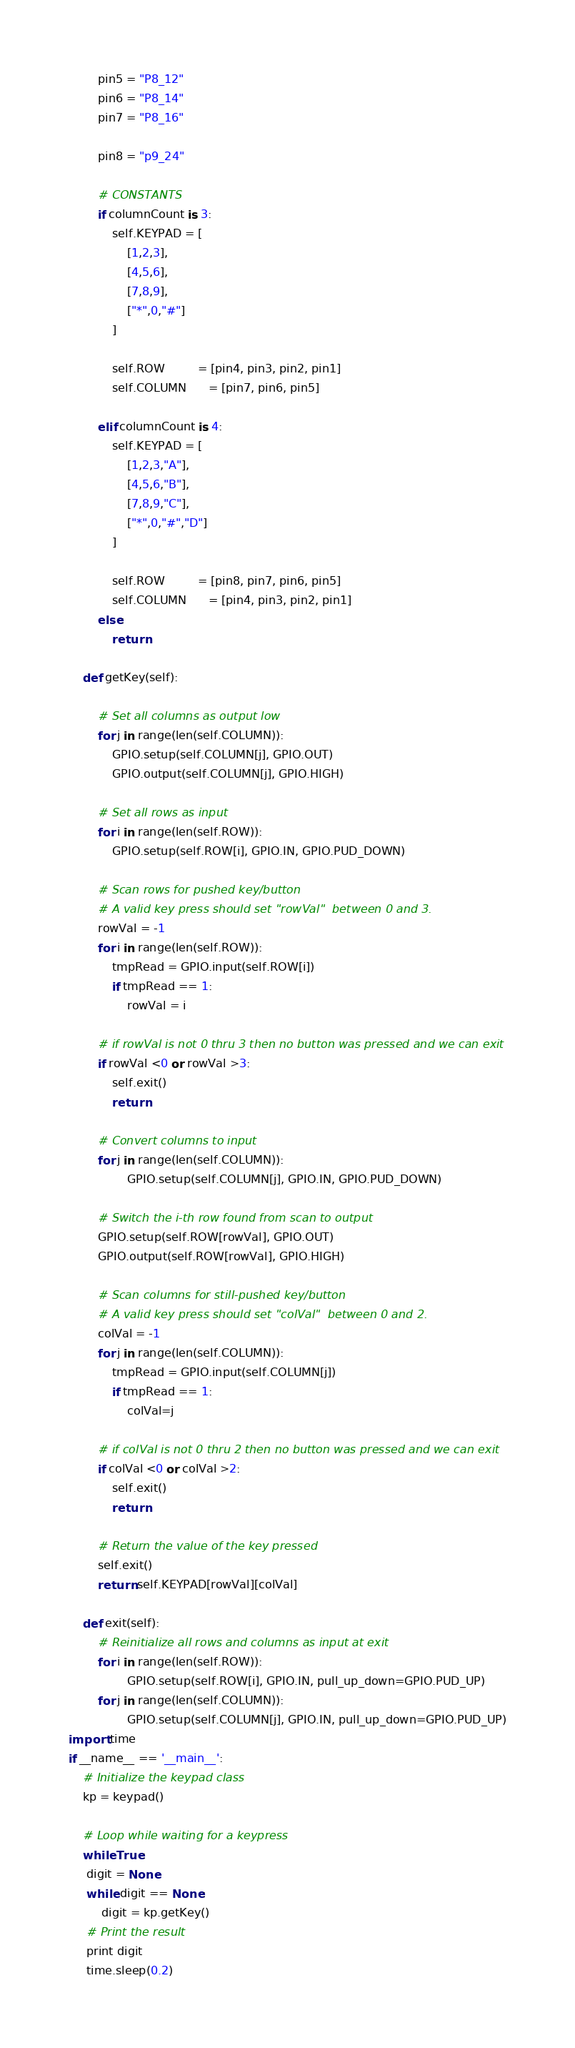<code> <loc_0><loc_0><loc_500><loc_500><_Python_>
        pin5 = "P8_12"
        pin6 = "P8_14"
        pin7 = "P8_16"

        pin8 = "p9_24"

        # CONSTANTS 
        if columnCount is 3:
            self.KEYPAD = [
                [1,2,3],
                [4,5,6],
                [7,8,9],
                ["*",0,"#"]
            ]

            self.ROW         = [pin4, pin3, pin2, pin1]
            self.COLUMN      = [pin7, pin6, pin5]

        elif columnCount is 4:
            self.KEYPAD = [
                [1,2,3,"A"],
                [4,5,6,"B"],
                [7,8,9,"C"],
                ["*",0,"#","D"]
            ]

            self.ROW         = [pin8, pin7, pin6, pin5]
            self.COLUMN      = [pin4, pin3, pin2, pin1]
        else:
            return
     
    def getKey(self):
         
        # Set all columns as output low
        for j in range(len(self.COLUMN)):
            GPIO.setup(self.COLUMN[j], GPIO.OUT)
            GPIO.output(self.COLUMN[j], GPIO.HIGH)
         
        # Set all rows as input
        for i in range(len(self.ROW)):
            GPIO.setup(self.ROW[i], GPIO.IN, GPIO.PUD_DOWN)
         
        # Scan rows for pushed key/button
        # A valid key press should set "rowVal"  between 0 and 3.
        rowVal = -1
        for i in range(len(self.ROW)):
            tmpRead = GPIO.input(self.ROW[i])
            if tmpRead == 1:
                rowVal = i
                 
        # if rowVal is not 0 thru 3 then no button was pressed and we can exit
        if rowVal <0 or rowVal >3:
            self.exit()
            return
         
        # Convert columns to input
        for j in range(len(self.COLUMN)):
                GPIO.setup(self.COLUMN[j], GPIO.IN, GPIO.PUD_DOWN)
         
        # Switch the i-th row found from scan to output
        GPIO.setup(self.ROW[rowVal], GPIO.OUT)
        GPIO.output(self.ROW[rowVal], GPIO.HIGH)
 
        # Scan columns for still-pushed key/button
        # A valid key press should set "colVal"  between 0 and 2.
        colVal = -1
        for j in range(len(self.COLUMN)):
            tmpRead = GPIO.input(self.COLUMN[j])
            if tmpRead == 1:
                colVal=j
                 
        # if colVal is not 0 thru 2 then no button was pressed and we can exit
        if colVal <0 or colVal >2:
            self.exit()
            return 
 
        # Return the value of the key pressed
        self.exit()
        return self.KEYPAD[rowVal][colVal]
         
    def exit(self):
        # Reinitialize all rows and columns as input at exit
        for i in range(len(self.ROW)):
                GPIO.setup(self.ROW[i], GPIO.IN, pull_up_down=GPIO.PUD_UP) 
        for j in range(len(self.COLUMN)):
                GPIO.setup(self.COLUMN[j], GPIO.IN, pull_up_down=GPIO.PUD_UP)
import time
if __name__ == '__main__':
    # Initialize the keypad class
    kp = keypad()
     
    # Loop while waiting for a keypress
    while True:
     digit = None
     while digit == None:
         digit = kp.getKey()
     # Print the result
     print digit
     time.sleep(0.2)
</code> 